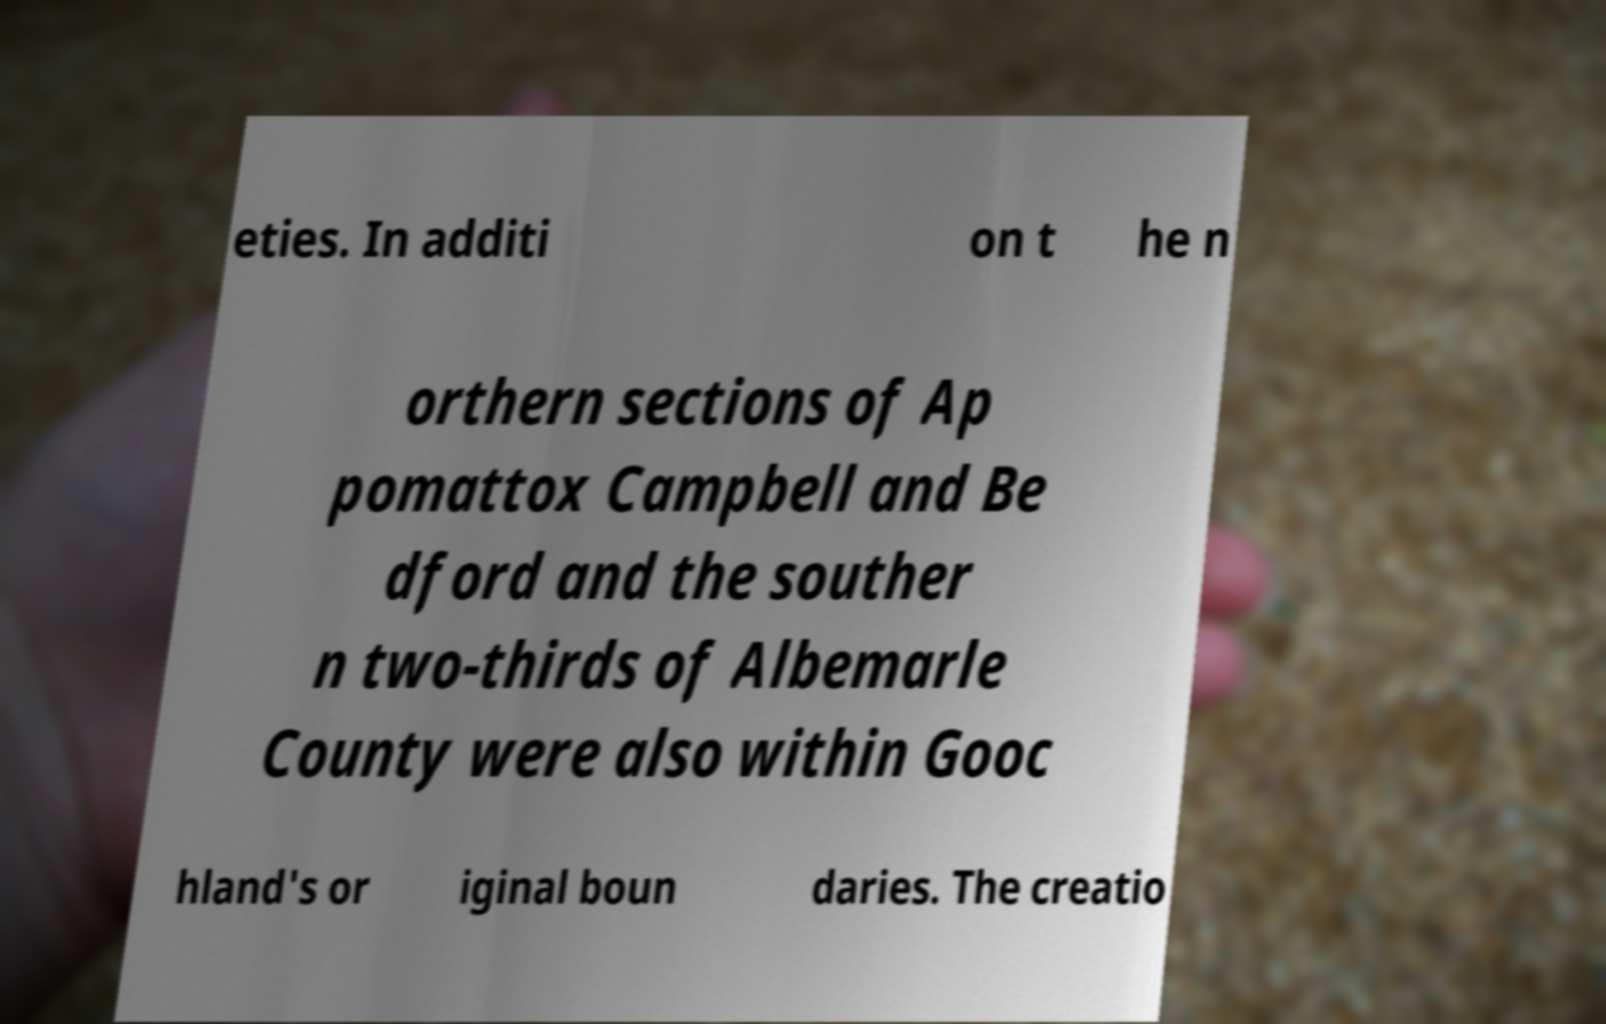Could you extract and type out the text from this image? eties. In additi on t he n orthern sections of Ap pomattox Campbell and Be dford and the souther n two-thirds of Albemarle County were also within Gooc hland's or iginal boun daries. The creatio 